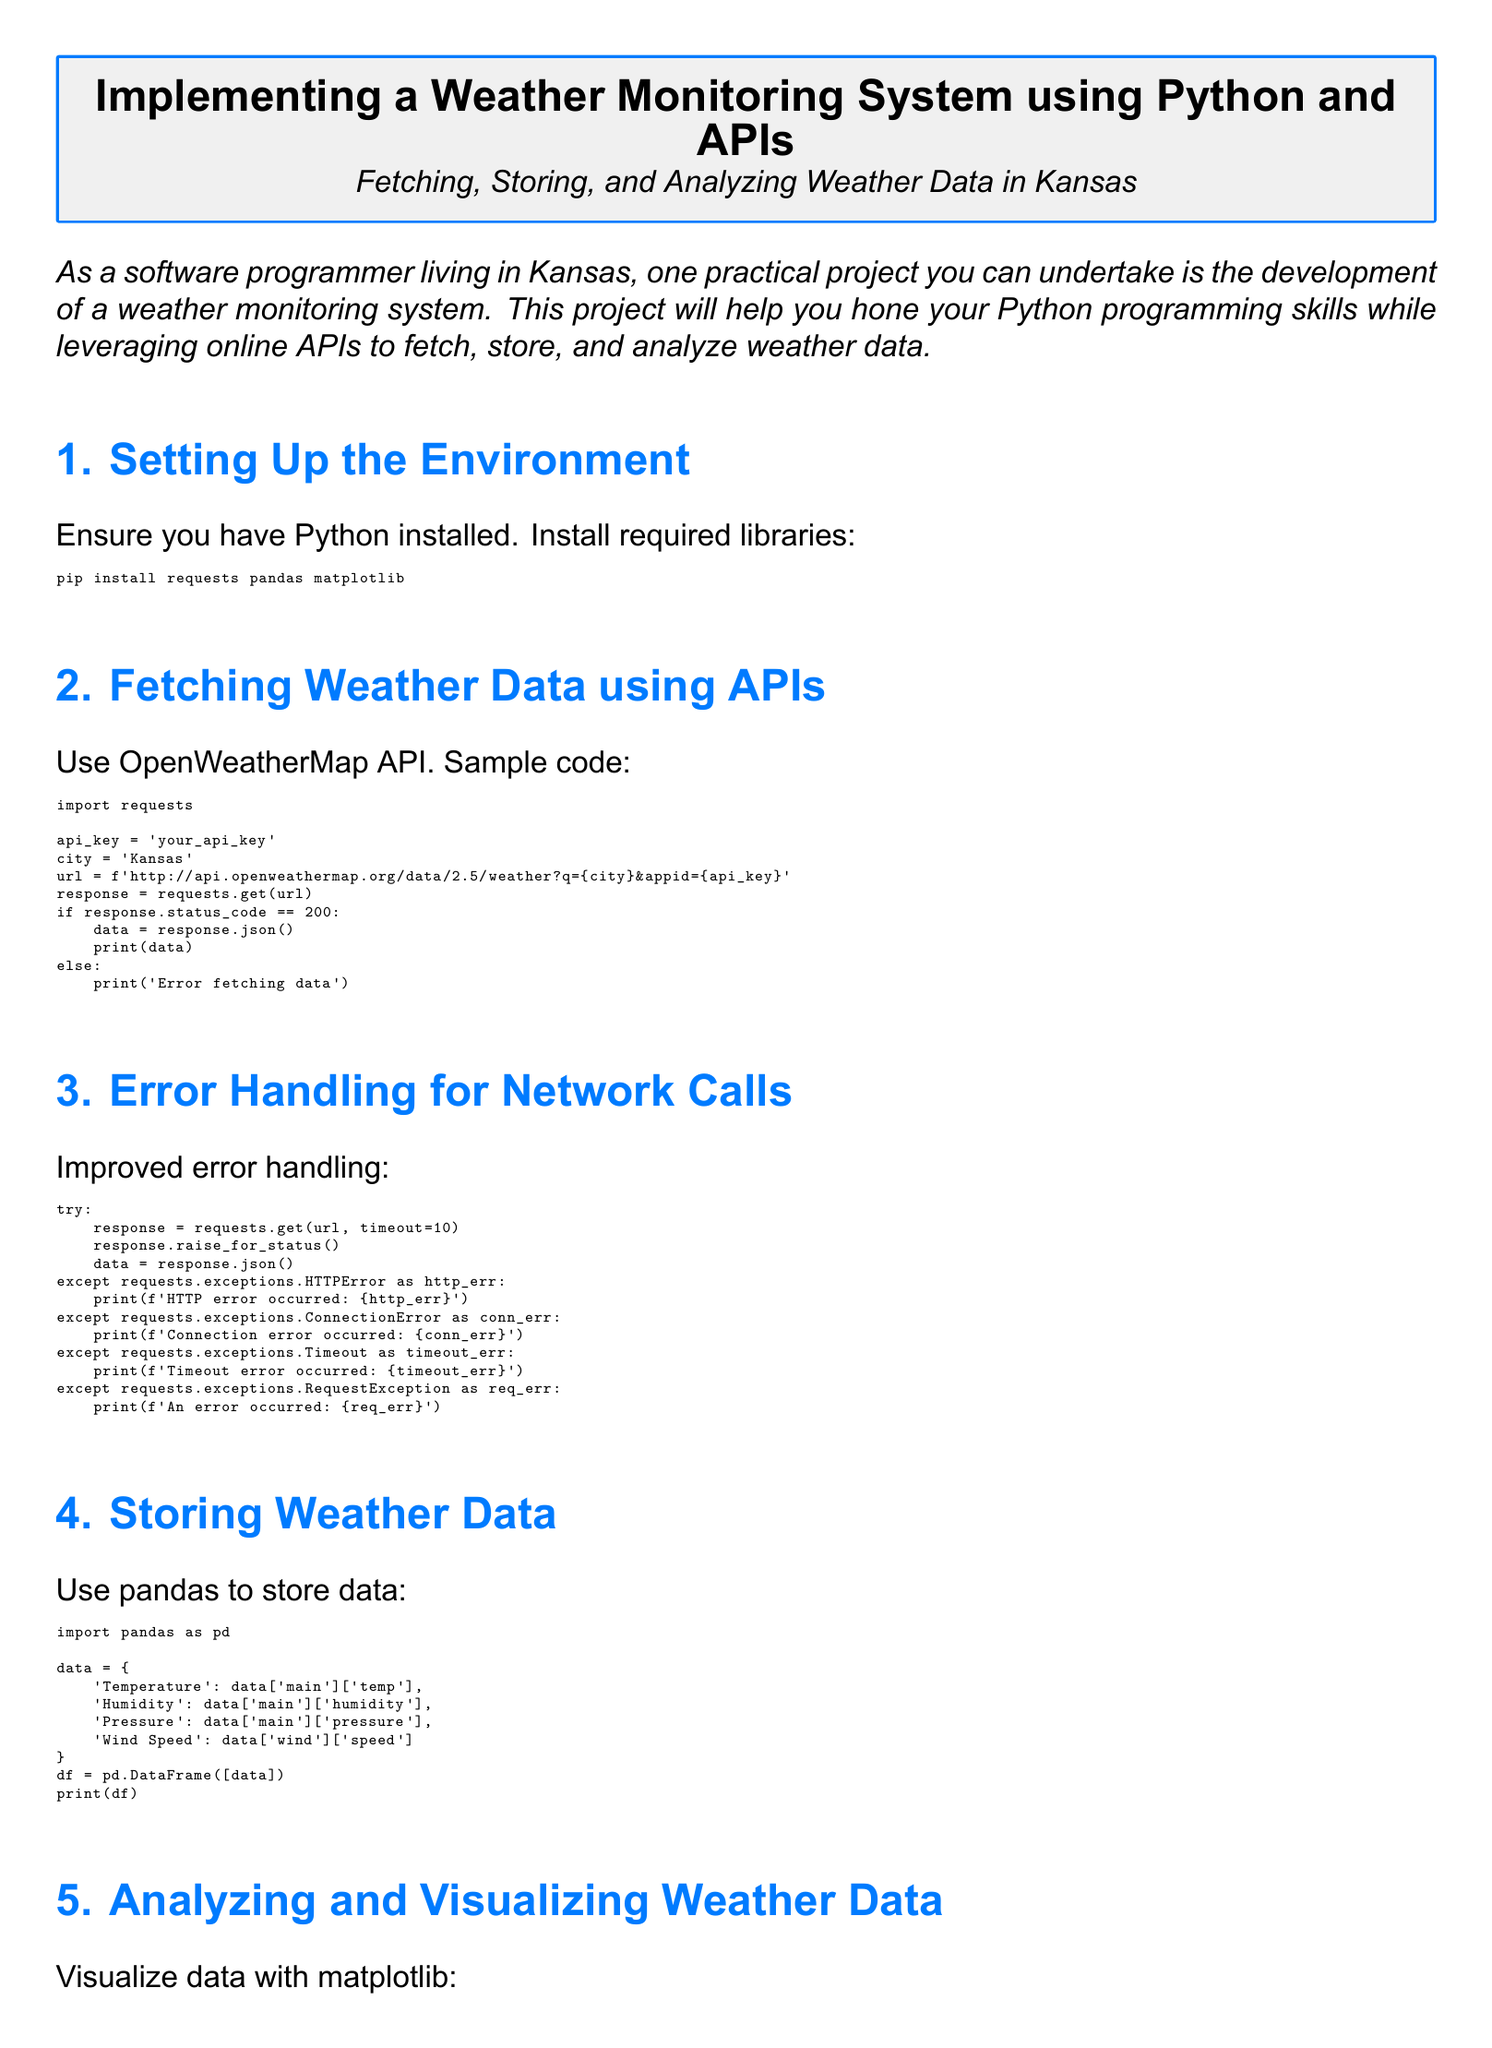What is the title of the homework? The title of the homework is explicitly stated at the beginning of the document as 'Implementing a Weather Monitoring System using Python and APIs.'
Answer: Implementing a Weather Monitoring System using Python and APIs Which library is used for data storage? The document states that pandas is used to store data, as indicated in the section on storing weather data.
Answer: pandas What API is recommended for fetching weather data? The recommended API for fetching weather data is mentioned as OpenWeatherMap API in the document.
Answer: OpenWeatherMap API How many types of error are specifically mentioned in the error handling section? The error handling section includes four specific types of exceptions related to requests: HTTPError, ConnectionError, Timeout, and RequestException. Therefore, there are four types.
Answer: Four What is the first step in setting up the environment? The first step is to ensure that Python is installed, which is stated in the document's setup section.
Answer: Ensure Python installed Which visualization library is utilized for plotting data? The library used for visualization, as stated in the relevant section of the document, is matplotlib.
Answer: matplotlib What type of analysis is performed on the weather data? The document indicates that the analysis performed is a visualization of the weather data through plotting it in a bar chart.
Answer: Visualization What metric is NOT included in the stored weather data? The stored weather data includes temperature, humidity, pressure, and wind speed; there is no mention of rainfall as a stored metric.
Answer: Rainfall 